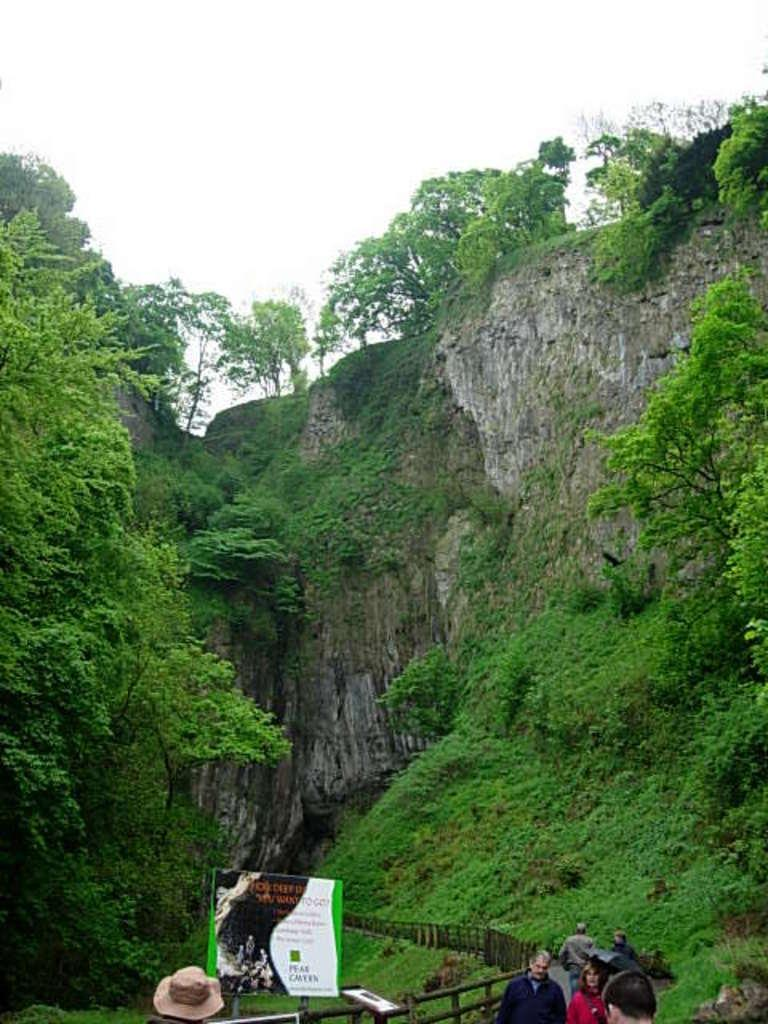What type of landscape feature is present in the image? There is a hill in the image. What type of vegetation can be seen in the image? There are trees in the image. Are there any people in the image? Yes, there are persons in the image. What type of man-made structure is visible in the image? There is a road in the image. What object can be seen with text on it? There is a board in the image. What type of barrier is present in the image? There is fencing in the image. What type of natural formation is visible in the image? There is a cave in the image. What part of the natural environment is visible in the image? The sky is visible in the image. How many knees are visible in the image? There are no knees visible in the image. What type of flying mammal can be seen in the image? There are no bats present in the image. 